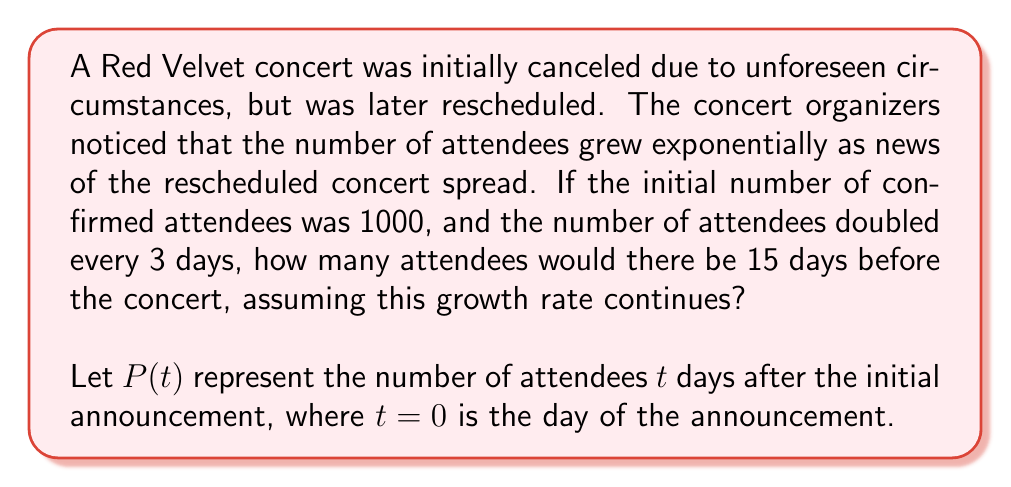What is the answer to this math problem? To solve this problem, we'll use the exponential growth model:

$$P(t) = P_0 \cdot b^t$$

Where:
$P(t)$ is the population at time $t$
$P_0$ is the initial population
$b$ is the growth factor per unit time
$t$ is the time elapsed

Given:
- Initial number of attendees, $P_0 = 1000$
- The population doubles every 3 days
- We want to know the number of attendees after 15 days

Step 1: Determine the growth factor $b$
Since the population doubles every 3 days, we can write:

$$2 = b^3$$

Solving for $b$:

$$b = 2^{\frac{1}{3}} \approx 1.2599$$

Step 2: Apply the exponential growth formula
Now we can use the formula with $t = 15$:

$$P(15) = 1000 \cdot (1.2599)^{15}$$

Step 3: Calculate the result
Using a calculator or computer:

$$P(15) = 1000 \cdot (1.2599)^{15} \approx 16,366.28$$

Rounding to the nearest whole number (as we can't have fractional attendees), we get 16,366 attendees.
Answer: 16,366 attendees 